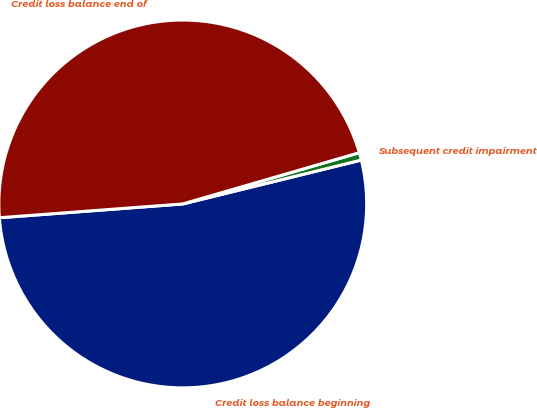<chart> <loc_0><loc_0><loc_500><loc_500><pie_chart><fcel>Credit loss balance beginning<fcel>Subsequent credit impairment<fcel>Credit loss balance end of<nl><fcel>52.64%<fcel>0.66%<fcel>46.7%<nl></chart> 